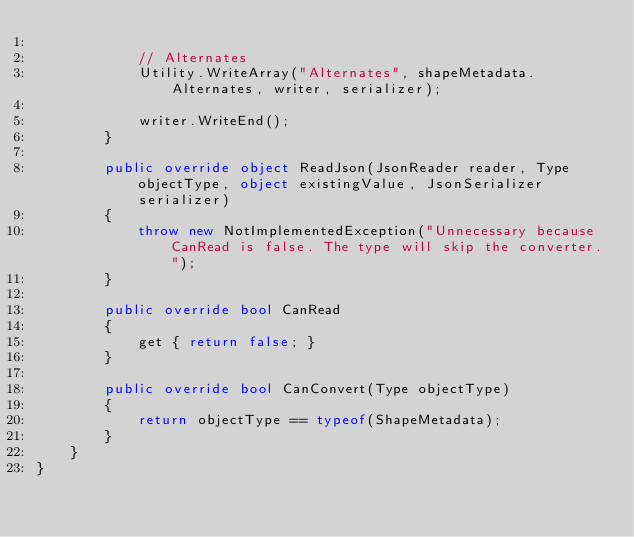Convert code to text. <code><loc_0><loc_0><loc_500><loc_500><_C#_>
            // Alternates
            Utility.WriteArray("Alternates", shapeMetadata.Alternates, writer, serializer);

            writer.WriteEnd();
        }

        public override object ReadJson(JsonReader reader, Type objectType, object existingValue, JsonSerializer serializer)
        {
            throw new NotImplementedException("Unnecessary because CanRead is false. The type will skip the converter.");
        }

        public override bool CanRead
        {
            get { return false; }
        }

        public override bool CanConvert(Type objectType)
        {
            return objectType == typeof(ShapeMetadata);
        }
    }
}</code> 